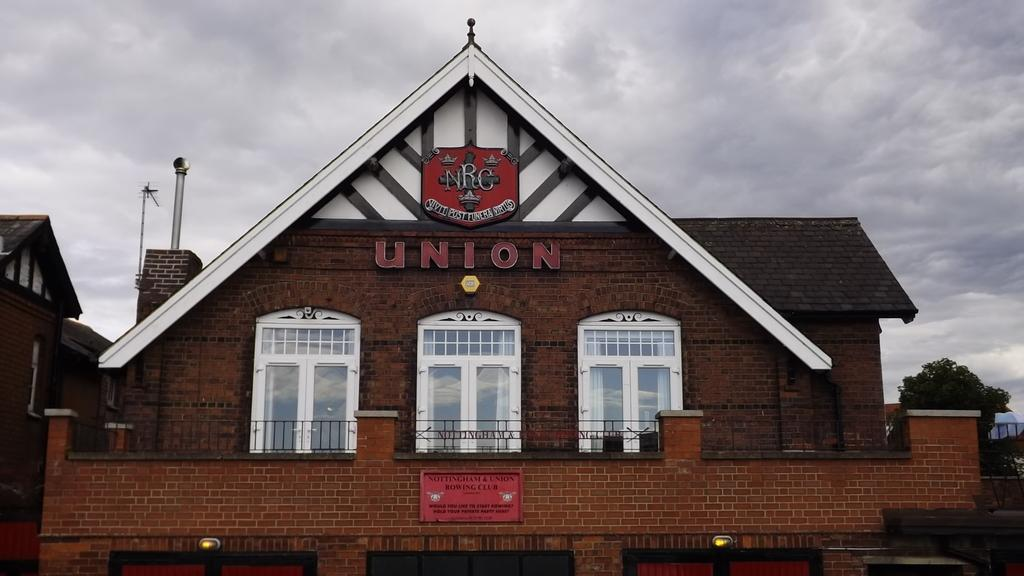What type of structure is in the image? There is a building in the image. What feature can be observed on the building? The building has glass windows. What colors are used for the building? The building is in brown and black color. What is attached to the wall of the building? There is a red color board attached to the wall. What type of vegetation is visible in the image? There are trees visible in the image. What is the condition of the sky in the image? The sky is cloudy in the image. How many pairs of shoes can be seen on the red color board in the image? There are no shoes present on the red color board in the image. What type of fact is being exchanged between the trees in the image? There is no exchange of facts between the trees in the image, as trees do not communicate in this manner. 